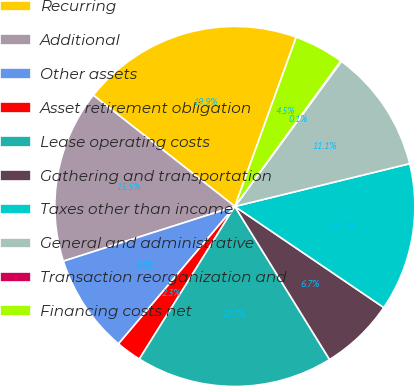<chart> <loc_0><loc_0><loc_500><loc_500><pie_chart><fcel>Recurring<fcel>Additional<fcel>Other assets<fcel>Asset retirement obligation<fcel>Lease operating costs<fcel>Gathering and transportation<fcel>Taxes other than income<fcel>General and administrative<fcel>Transaction reorganization and<fcel>Financing costs net<nl><fcel>19.93%<fcel>15.52%<fcel>8.9%<fcel>2.28%<fcel>17.72%<fcel>6.69%<fcel>13.31%<fcel>11.1%<fcel>0.07%<fcel>4.48%<nl></chart> 